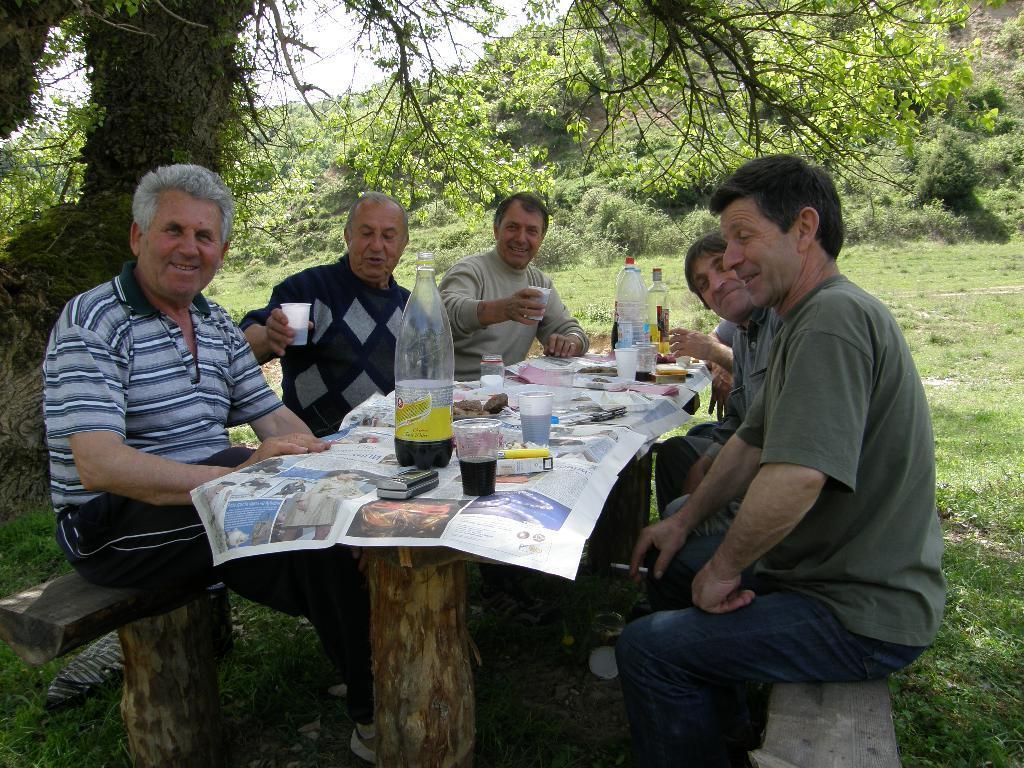Describe this image in one or two sentences. In this image, There is a table made of wood which is covered by a newspaper, there are some bottles and glasses on the table, The are some people sitting around the table, In the background there are some plants and trees in green color and there is a sky in white color. 